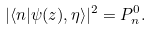<formula> <loc_0><loc_0><loc_500><loc_500>| \langle n | \psi ( z ) , \eta \rangle | ^ { 2 } = P _ { n } ^ { 0 } .</formula> 